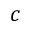Convert formula to latex. <formula><loc_0><loc_0><loc_500><loc_500>c</formula> 